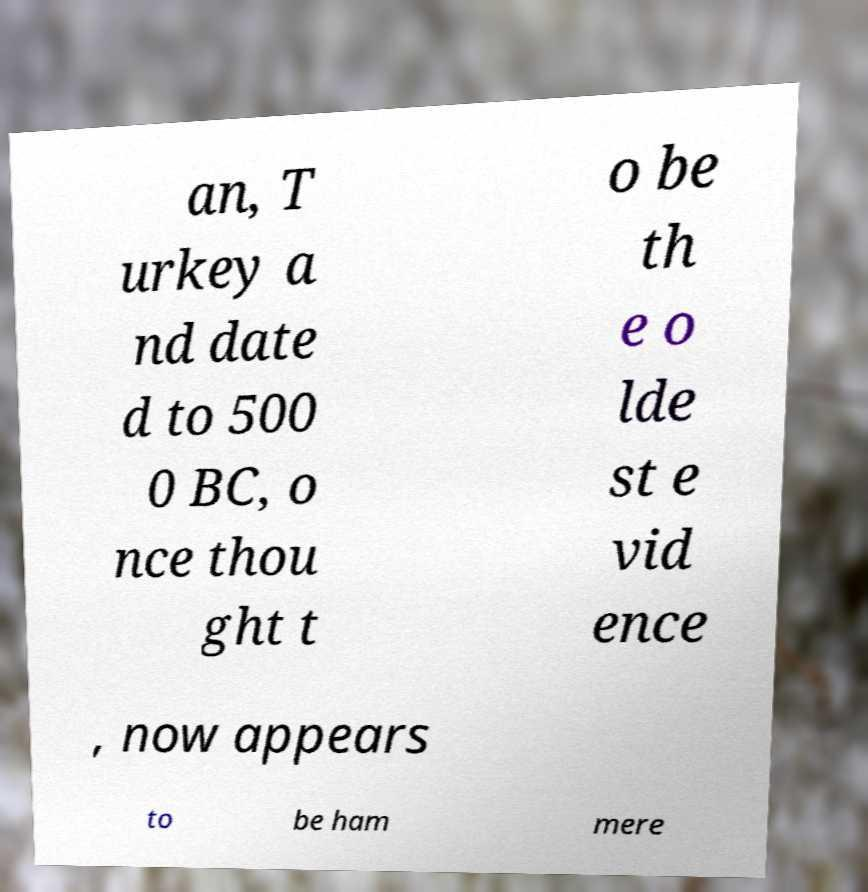Can you read and provide the text displayed in the image?This photo seems to have some interesting text. Can you extract and type it out for me? an, T urkey a nd date d to 500 0 BC, o nce thou ght t o be th e o lde st e vid ence , now appears to be ham mere 